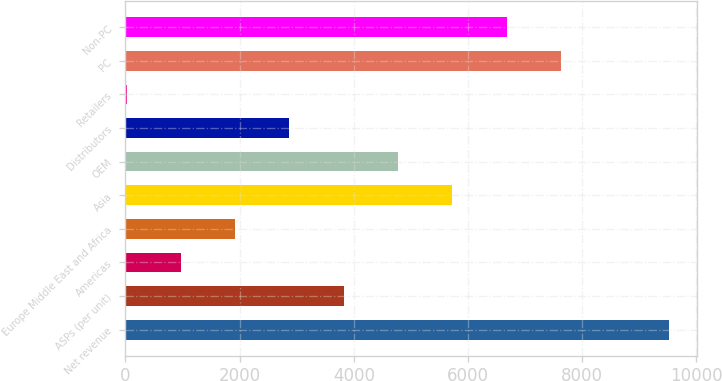Convert chart. <chart><loc_0><loc_0><loc_500><loc_500><bar_chart><fcel>Net revenue<fcel>ASPs (per unit)<fcel>Americas<fcel>Europe Middle East and Africa<fcel>Asia<fcel>OEM<fcel>Distributors<fcel>Retailers<fcel>PC<fcel>Non-PC<nl><fcel>9526<fcel>3821.8<fcel>969.7<fcel>1920.4<fcel>5723.2<fcel>4772.5<fcel>2871.1<fcel>19<fcel>7624.6<fcel>6673.9<nl></chart> 